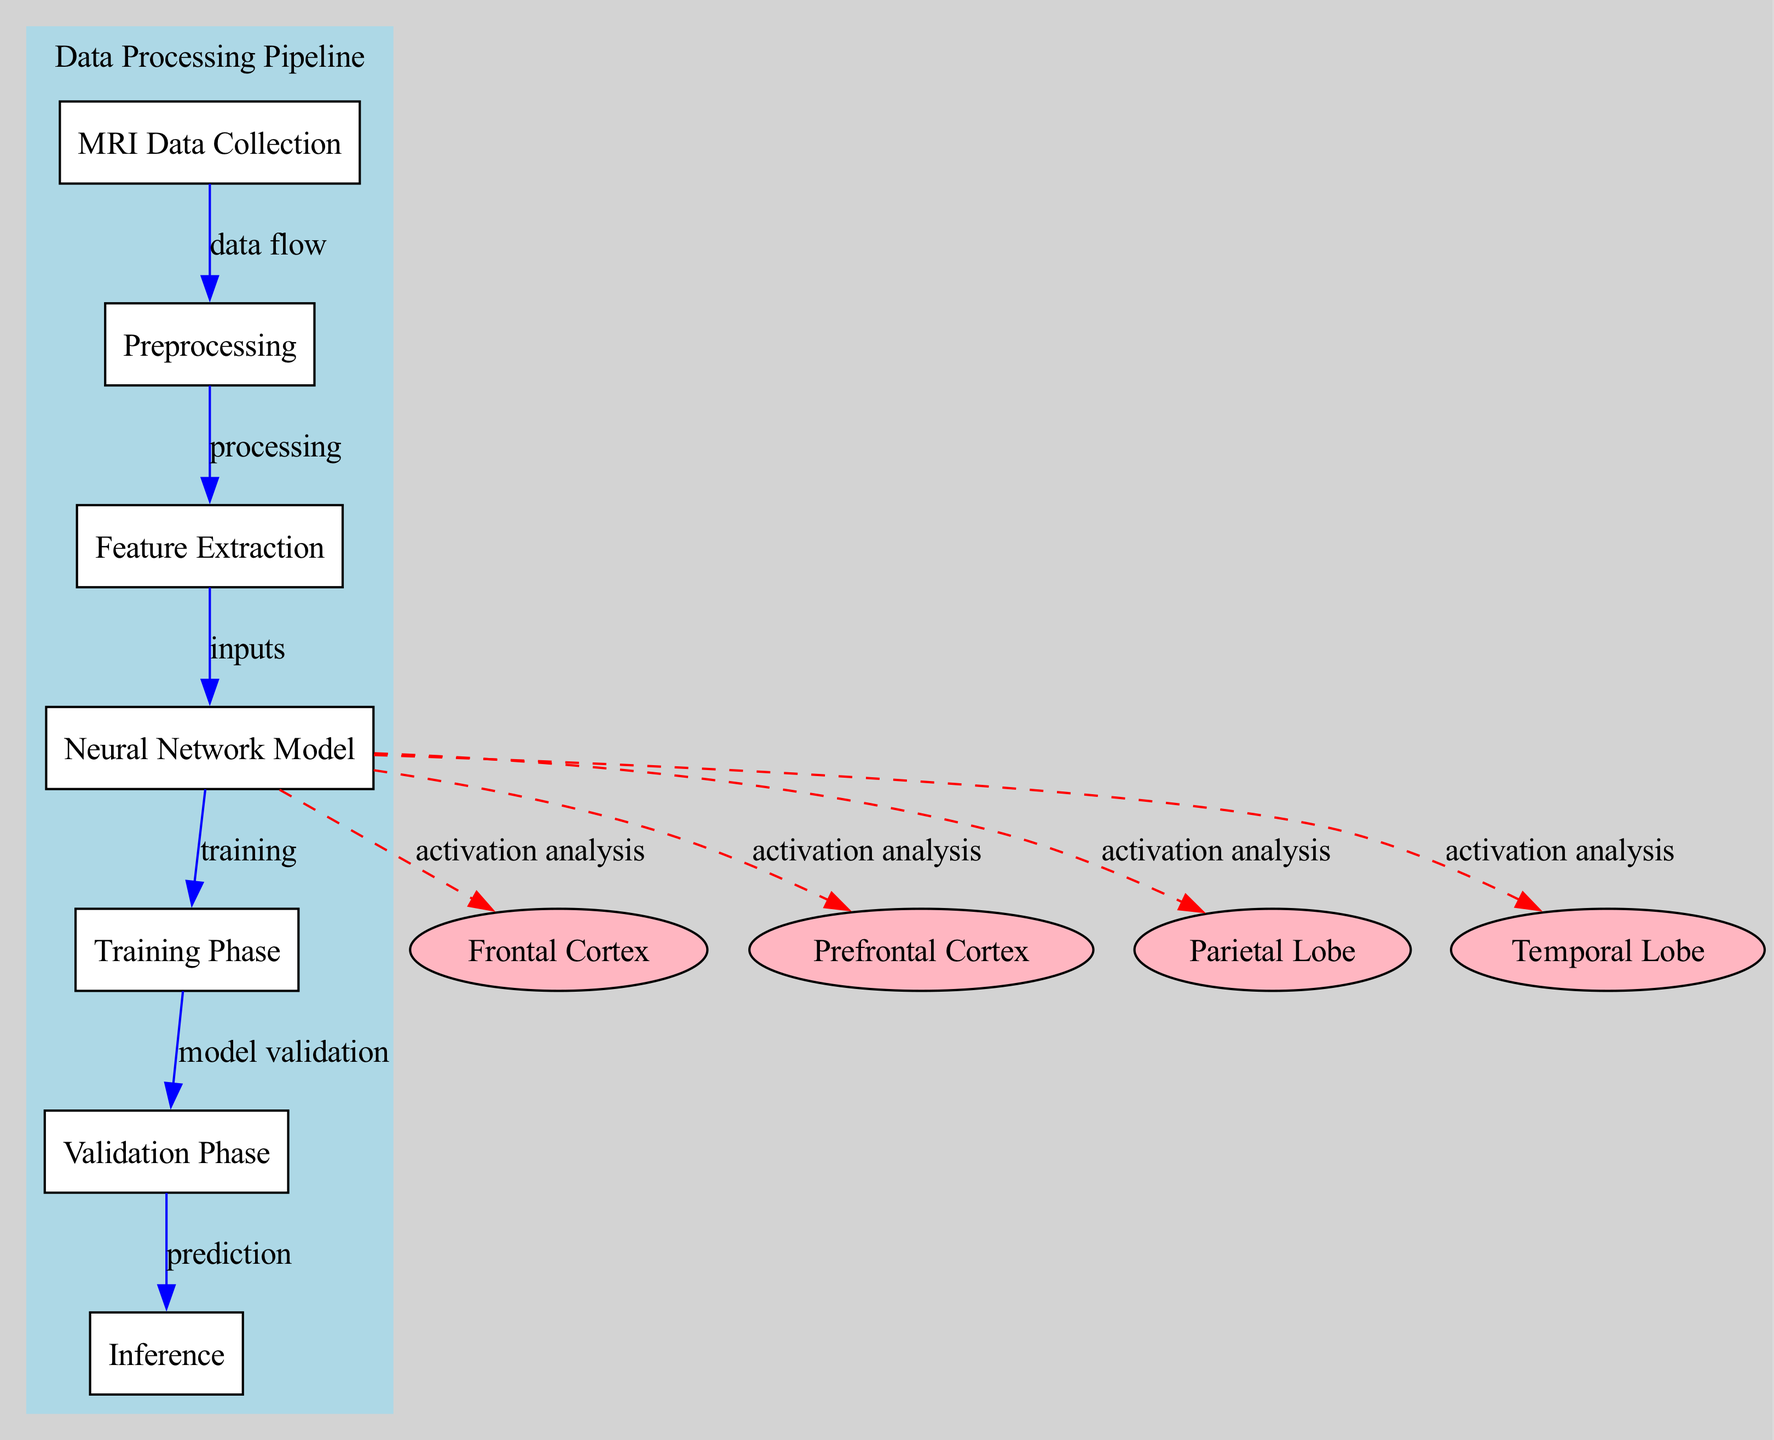What is the first step in the diagram? The first step is labeled "MRI Data Collection" and involves collecting MRI scans of counterintelligence agents during cognitive tasks.
Answer: MRI Data Collection How many nodes represent brain regions in the diagram? There are four nodes that represent brain regions: Frontal Cortex, Prefrontal Cortex, Parietal Lobe, and Temporal Lobe.
Answer: 4 What type of relationship is illustrated between the "Neural Network Model" and the "Frontal Cortex"? The relationship is indicated by a dashed red edge labeled "activation analysis" implying that the neural network model analyzes activation in the Frontal Cortex.
Answer: activation analysis What happens after the "Training Phase"? After the Training Phase, the next step is the Validation Phase which is used to validate the model's performance using a separate dataset.
Answer: Validation Phase Which step directly follows "Feature Extraction"? The step that directly follows "Feature Extraction" is "Neural Network Model" where the extracted features are used as inputs for simulating cognitive processes.
Answer: Neural Network Model How many total edges are connecting the nodes in the diagram? The diagram has a total of ten edges connecting the various nodes to illustrate the flow of data and relationships among them.
Answer: 10 Which brain region is specifically identified with complex decision-making activities? The brain region specifically associated with complex decision-making is the Prefrontal Cortex.
Answer: Prefrontal Cortex What process is labeled as "model validation" in the diagram? The process labeled as "model validation" is the Validation Phase, where the performance of the neural network model is evaluated using a separate dataset.
Answer: Validation Phase What is the purpose of the "Inference" node? The purpose of the Inference node is to predict brain activity during new problem-solving tasks based on the trained neural network model.
Answer: Predicting brain activity 